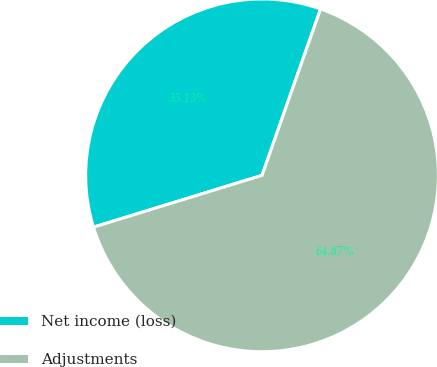Convert chart. <chart><loc_0><loc_0><loc_500><loc_500><pie_chart><fcel>Net income (loss)<fcel>Adjustments<nl><fcel>35.13%<fcel>64.87%<nl></chart> 